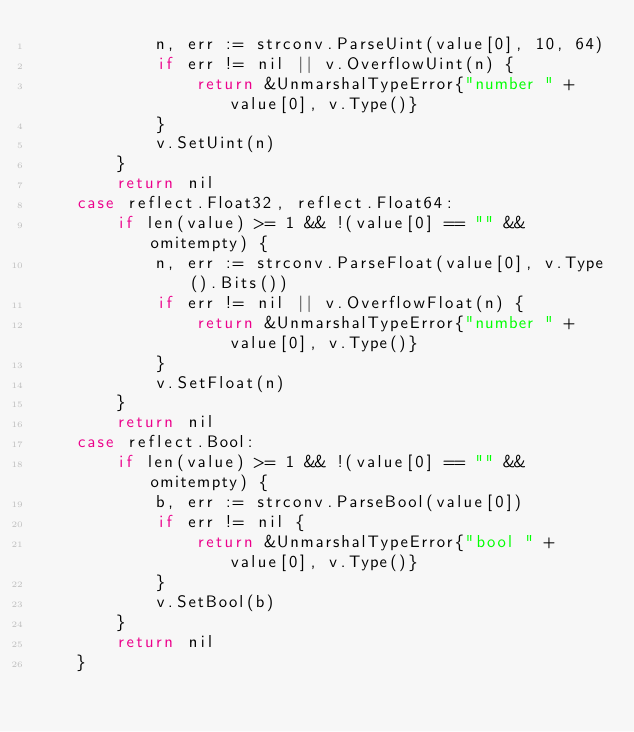<code> <loc_0><loc_0><loc_500><loc_500><_Go_>			n, err := strconv.ParseUint(value[0], 10, 64)
			if err != nil || v.OverflowUint(n) {
				return &UnmarshalTypeError{"number " + value[0], v.Type()}
			}
			v.SetUint(n)
		}
		return nil
	case reflect.Float32, reflect.Float64:
		if len(value) >= 1 && !(value[0] == "" && omitempty) {
			n, err := strconv.ParseFloat(value[0], v.Type().Bits())
			if err != nil || v.OverflowFloat(n) {
				return &UnmarshalTypeError{"number " + value[0], v.Type()}
			}
			v.SetFloat(n)
		}
		return nil
	case reflect.Bool:
		if len(value) >= 1 && !(value[0] == "" && omitempty) {
			b, err := strconv.ParseBool(value[0])
			if err != nil {
				return &UnmarshalTypeError{"bool " + value[0], v.Type()}
			}
			v.SetBool(b)
		}
		return nil
	}</code> 